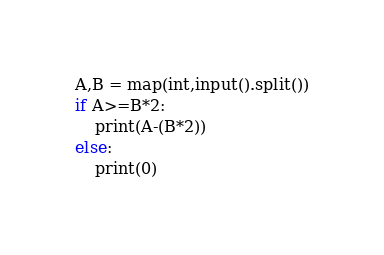Convert code to text. <code><loc_0><loc_0><loc_500><loc_500><_Python_>A,B = map(int,input().split())
if A>=B*2:
    print(A-(B*2))
else:
    print(0)
</code> 